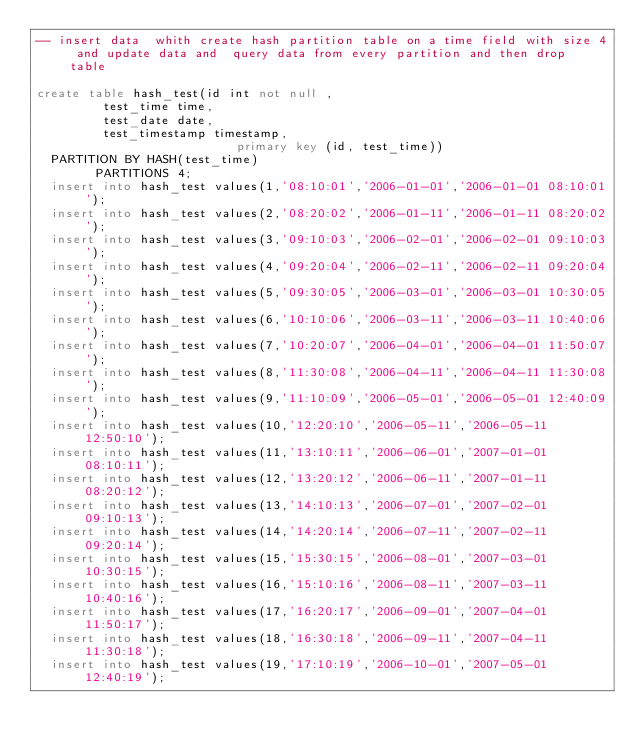<code> <loc_0><loc_0><loc_500><loc_500><_SQL_>-- insert data  whith create hash partition table on a time field with size 4 and update data and  query data from every partition and then drop table

create table hash_test(id int not null ,	
			   test_time time,
			   test_date date,
			   test_timestamp timestamp,
                           primary key (id, test_time))
	PARTITION BY HASH(test_time)
        PARTITIONS 4;
	insert into hash_test values(1,'08:10:01','2006-01-01','2006-01-01 08:10:01');
	insert into hash_test values(2,'08:20:02','2006-01-11','2006-01-11 08:20:02');
	insert into hash_test values(3,'09:10:03','2006-02-01','2006-02-01 09:10:03');
	insert into hash_test values(4,'09:20:04','2006-02-11','2006-02-11 09:20:04');
	insert into hash_test values(5,'09:30:05','2006-03-01','2006-03-01 10:30:05');
	insert into hash_test values(6,'10:10:06','2006-03-11','2006-03-11 10:40:06');
	insert into hash_test values(7,'10:20:07','2006-04-01','2006-04-01 11:50:07');
	insert into hash_test values(8,'11:30:08','2006-04-11','2006-04-11 11:30:08');
	insert into hash_test values(9,'11:10:09','2006-05-01','2006-05-01 12:40:09');
	insert into hash_test values(10,'12:20:10','2006-05-11','2006-05-11 12:50:10');
	insert into hash_test values(11,'13:10:11','2006-06-01','2007-01-01 08:10:11');
	insert into hash_test values(12,'13:20:12','2006-06-11','2007-01-11 08:20:12');
	insert into hash_test values(13,'14:10:13','2006-07-01','2007-02-01 09:10:13');
	insert into hash_test values(14,'14:20:14','2006-07-11','2007-02-11 09:20:14');
	insert into hash_test values(15,'15:30:15','2006-08-01','2007-03-01 10:30:15');
	insert into hash_test values(16,'15:10:16','2006-08-11','2007-03-11 10:40:16');
	insert into hash_test values(17,'16:20:17','2006-09-01','2007-04-01 11:50:17');
	insert into hash_test values(18,'16:30:18','2006-09-11','2007-04-11 11:30:18');
	insert into hash_test values(19,'17:10:19','2006-10-01','2007-05-01 12:40:19');</code> 